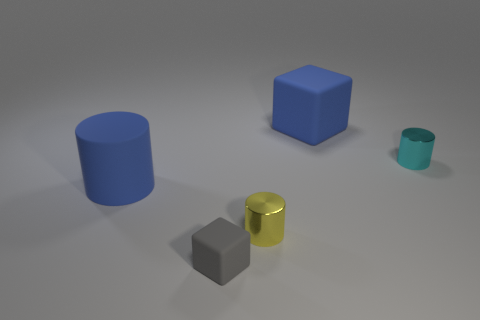Subtract all small cylinders. How many cylinders are left? 1 Add 4 gray rubber things. How many objects exist? 9 Subtract all cyan cylinders. How many cylinders are left? 2 Subtract all cylinders. How many objects are left? 2 Add 4 yellow shiny things. How many yellow shiny things are left? 5 Add 3 blue rubber cylinders. How many blue rubber cylinders exist? 4 Subtract 0 yellow blocks. How many objects are left? 5 Subtract all yellow cylinders. Subtract all red spheres. How many cylinders are left? 2 Subtract all gray spheres. How many gray cylinders are left? 0 Subtract all tiny yellow metal cylinders. Subtract all blue matte objects. How many objects are left? 2 